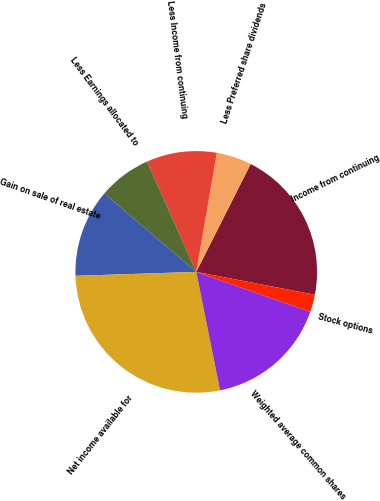Convert chart to OTSL. <chart><loc_0><loc_0><loc_500><loc_500><pie_chart><fcel>Income from continuing<fcel>Less Preferred share dividends<fcel>Less Income from continuing<fcel>Less Earnings allocated to<fcel>Gain on sale of real estate<fcel>Net income available for<fcel>Weighted average common shares<fcel>Stock options<nl><fcel>20.59%<fcel>4.71%<fcel>9.41%<fcel>7.06%<fcel>11.77%<fcel>27.64%<fcel>16.47%<fcel>2.35%<nl></chart> 